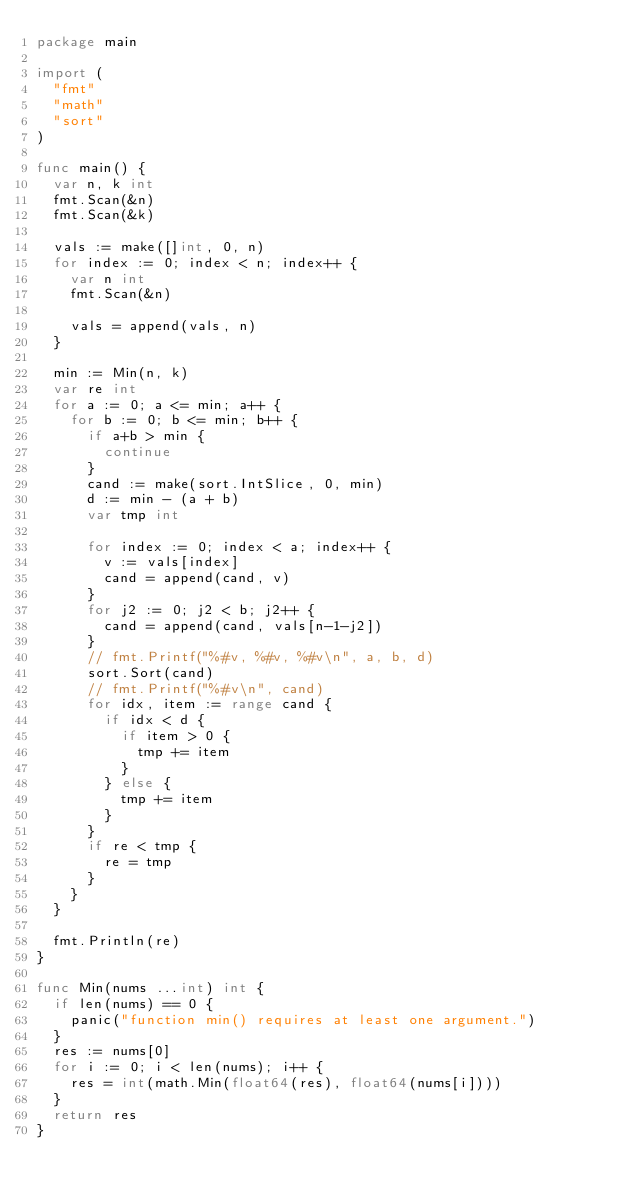Convert code to text. <code><loc_0><loc_0><loc_500><loc_500><_Go_>package main

import (
	"fmt"
	"math"
	"sort"
)

func main() {
	var n, k int
	fmt.Scan(&n)
	fmt.Scan(&k)

	vals := make([]int, 0, n)
	for index := 0; index < n; index++ {
		var n int
		fmt.Scan(&n)

		vals = append(vals, n)
	}

	min := Min(n, k)
	var re int
	for a := 0; a <= min; a++ {
		for b := 0; b <= min; b++ {
			if a+b > min {
				continue
			}
			cand := make(sort.IntSlice, 0, min)
			d := min - (a + b)
			var tmp int

			for index := 0; index < a; index++ {
				v := vals[index]
				cand = append(cand, v)
			}
			for j2 := 0; j2 < b; j2++ {
				cand = append(cand, vals[n-1-j2])
			}
			// fmt.Printf("%#v, %#v, %#v\n", a, b, d)
			sort.Sort(cand)
			// fmt.Printf("%#v\n", cand)
			for idx, item := range cand {
				if idx < d {
					if item > 0 {
						tmp += item
					}
				} else {
					tmp += item
				}
			}
			if re < tmp {
				re = tmp
			}
		}
	}

	fmt.Println(re)
}

func Min(nums ...int) int {
	if len(nums) == 0 {
		panic("function min() requires at least one argument.")
	}
	res := nums[0]
	for i := 0; i < len(nums); i++ {
		res = int(math.Min(float64(res), float64(nums[i])))
	}
	return res
}
</code> 